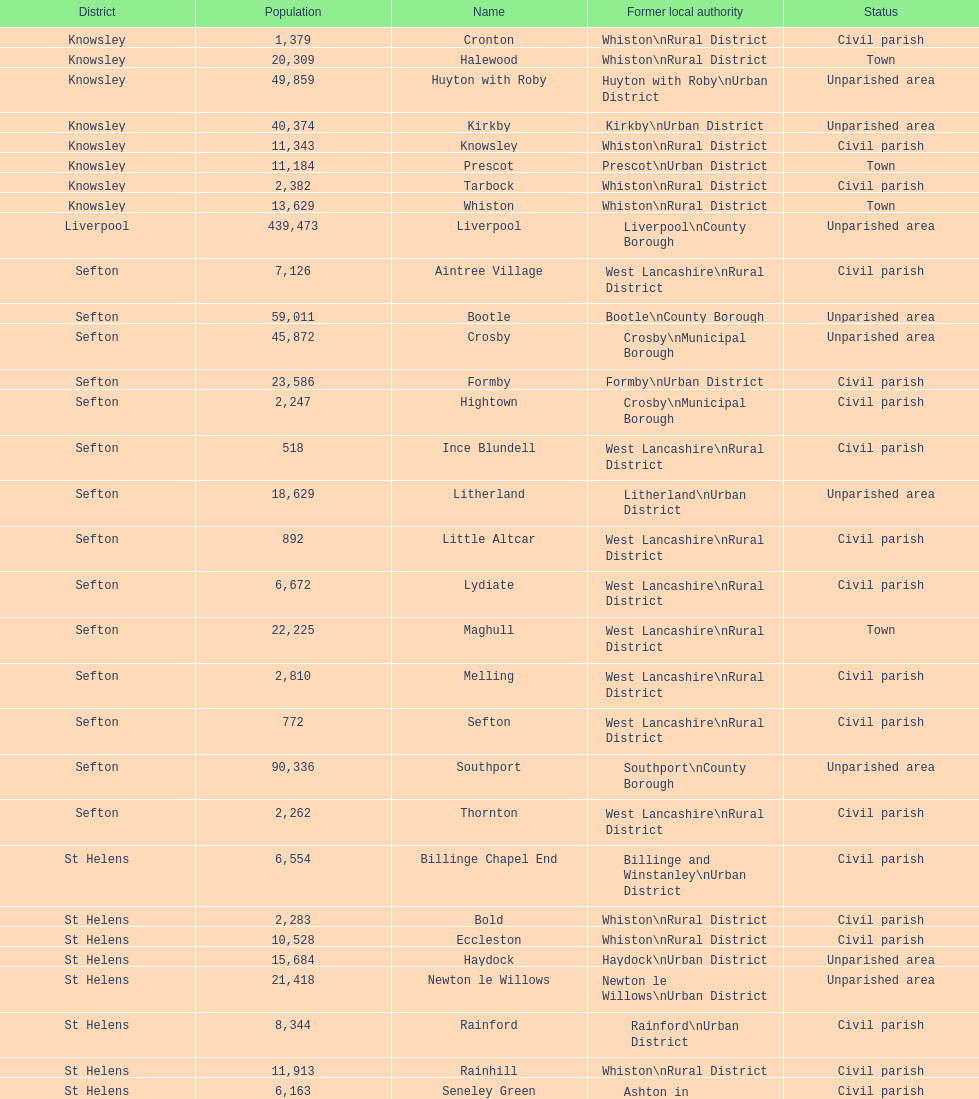Which is a civil parish, aintree village or maghull? Aintree Village. 